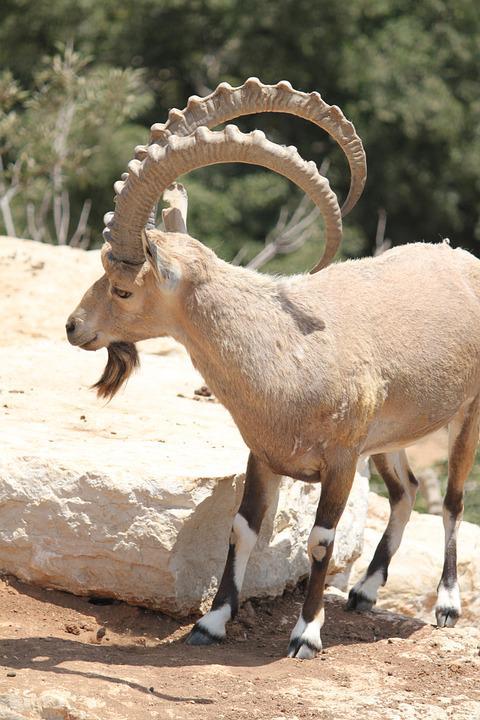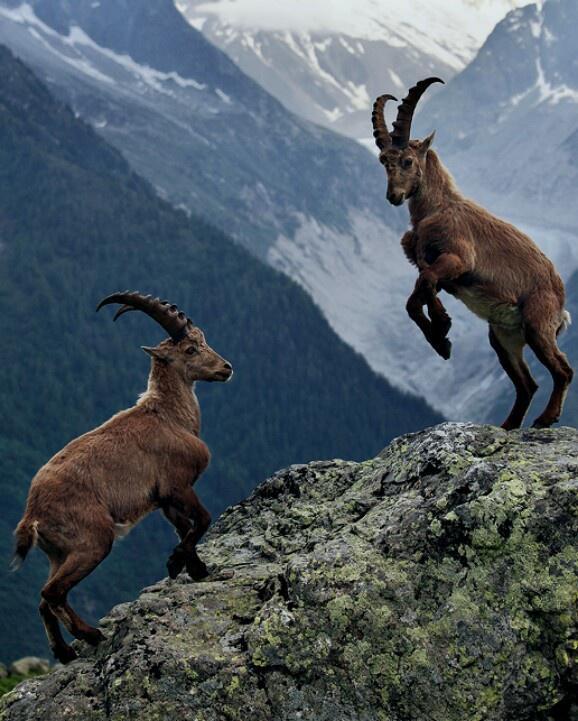The first image is the image on the left, the second image is the image on the right. Assess this claim about the two images: "The right image contains two animals standing on a rock.". Correct or not? Answer yes or no. Yes. The first image is the image on the left, the second image is the image on the right. Assess this claim about the two images: "An image shows two horned animals facing toward each other on a stony slope.". Correct or not? Answer yes or no. Yes. 